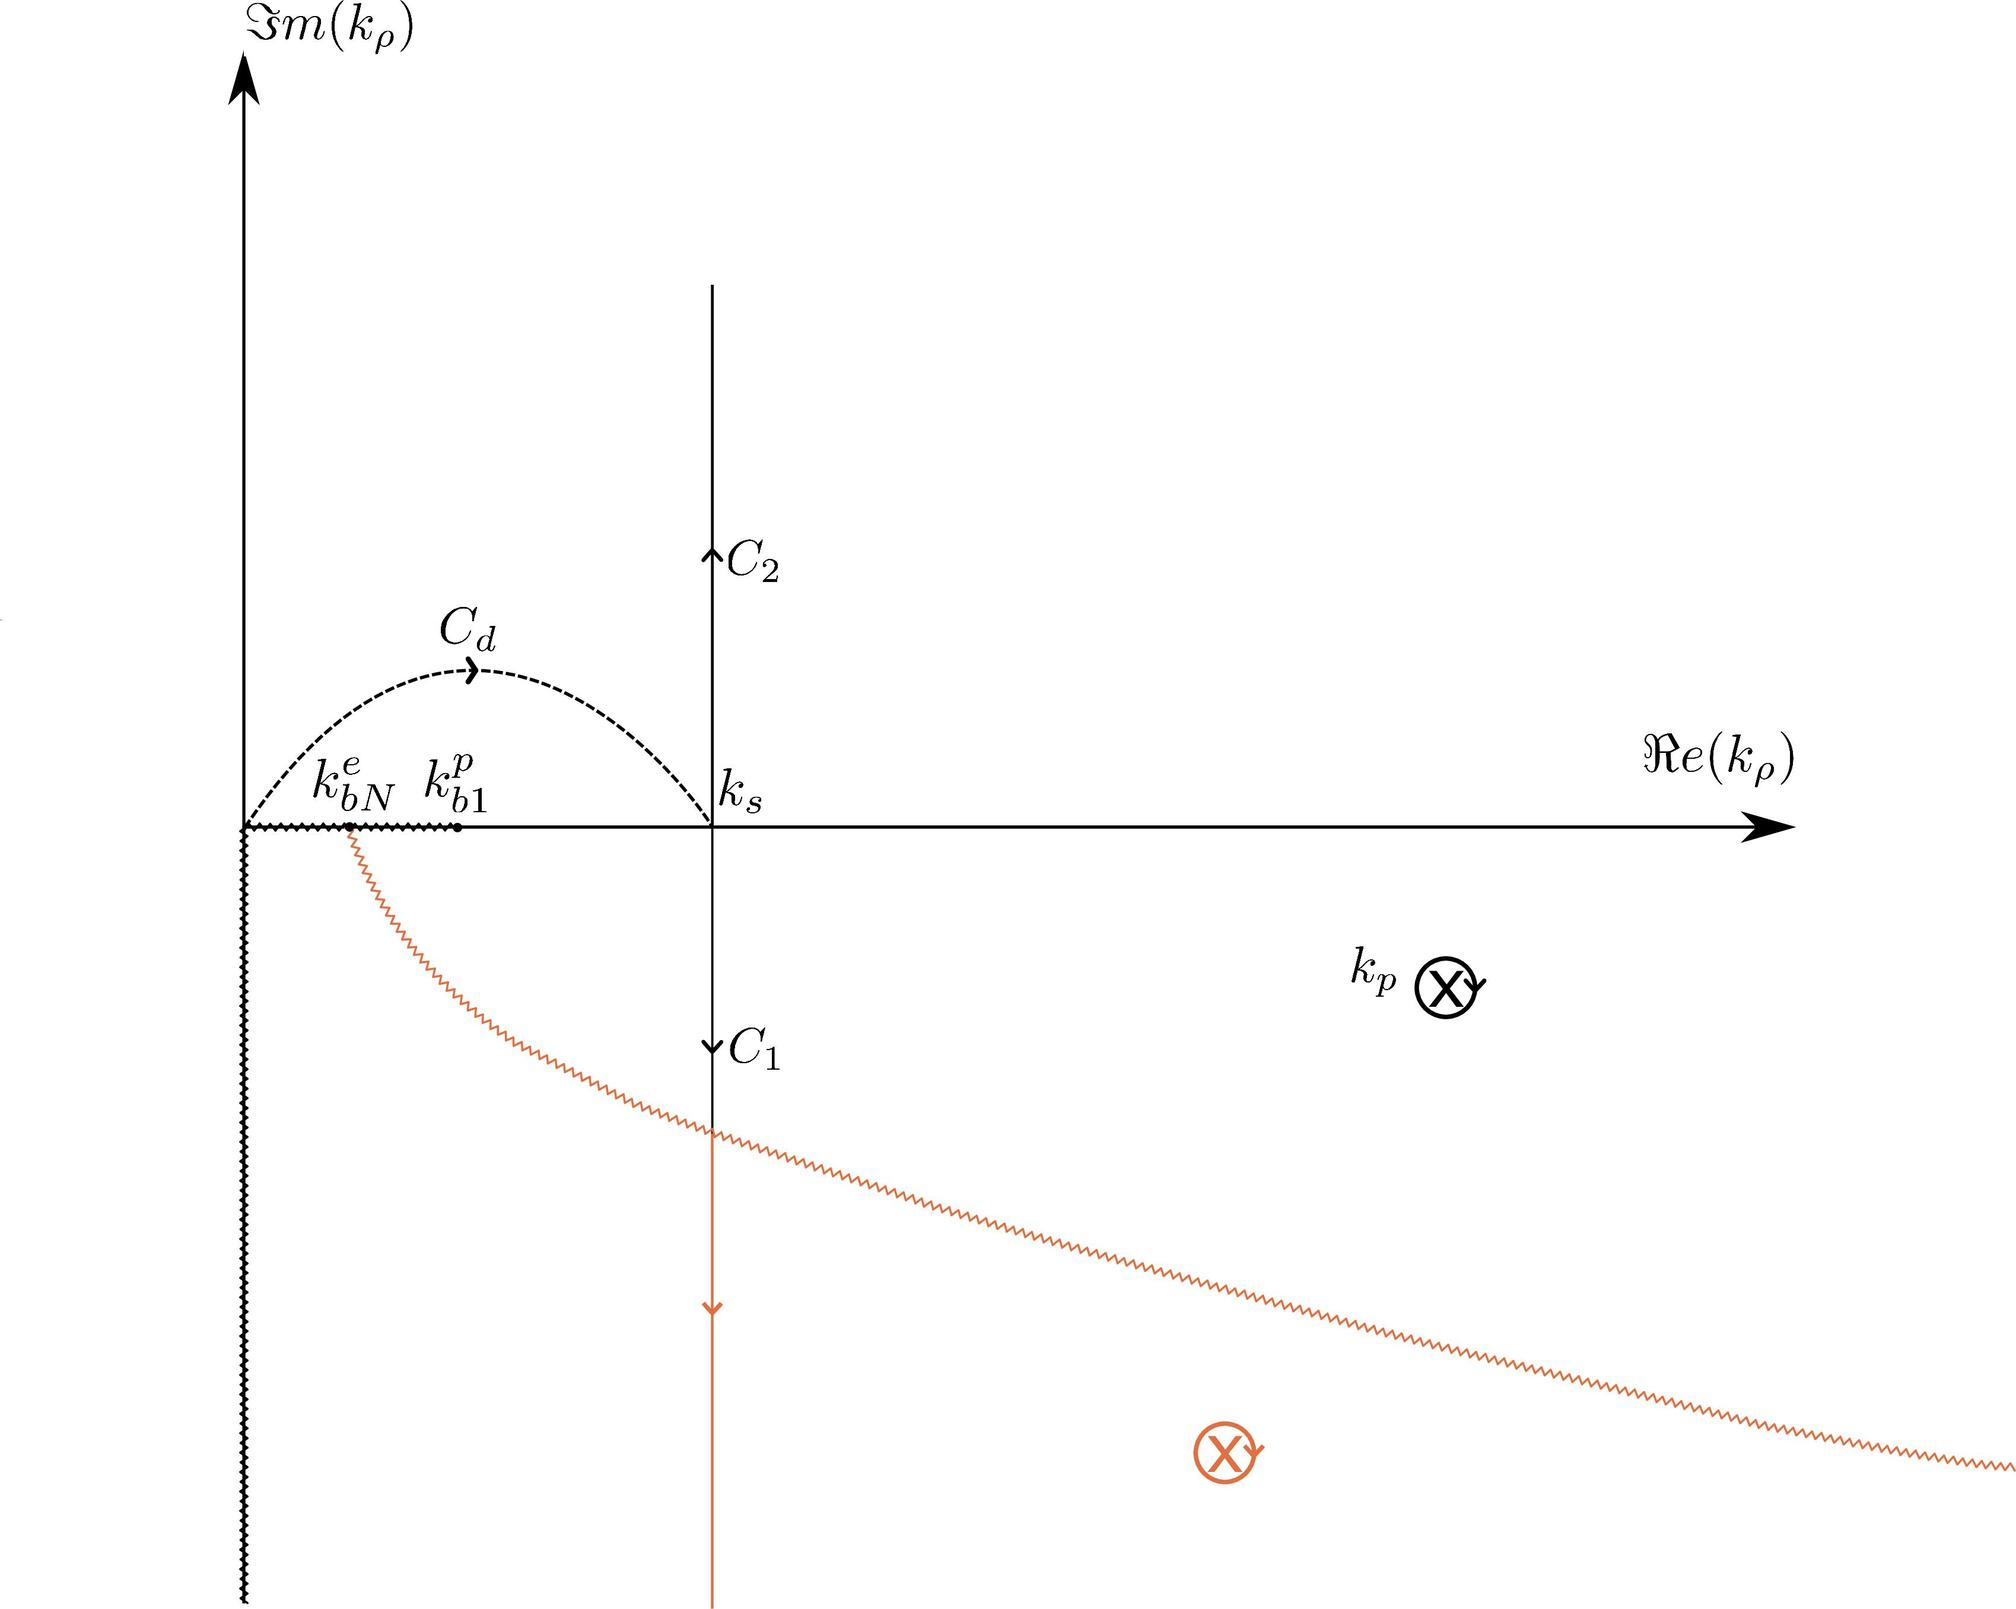What is the role of the coordinate lines labeled as \( Re(k_p) \) and \( Sm(k_p) \)? The coordinate lines labeled as \( Re(k_p) \) and \( Sm(k_p) \) denote the real part and the imaginary part of the complex variable \( k_p \), respectively. These axes are fundamental in complex analysis as they help in visually representing complex numbers and functions. The real axis, \( Re(k_p) \), and the imaginary axis, \( Sm(k_p) \), together form a two-dimensional space where complex numbers can be plotted. This setup is essential for understanding properties such as continuity, limits, and paths of integration within the complex domain. 